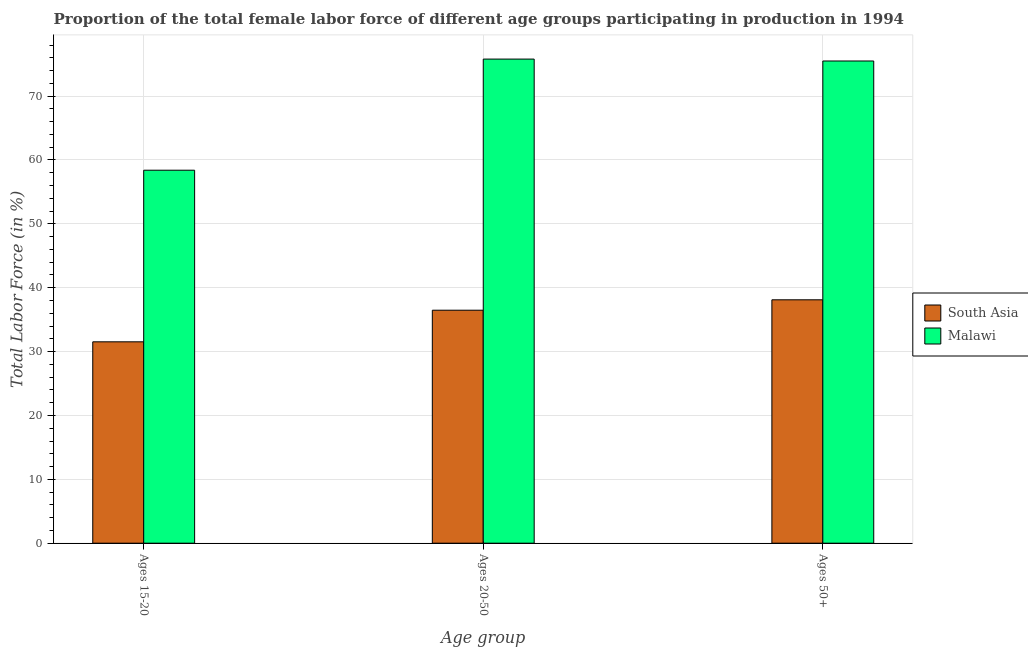Are the number of bars per tick equal to the number of legend labels?
Your answer should be very brief. Yes. Are the number of bars on each tick of the X-axis equal?
Your answer should be very brief. Yes. What is the label of the 2nd group of bars from the left?
Your answer should be compact. Ages 20-50. What is the percentage of female labor force above age 50 in Malawi?
Give a very brief answer. 75.5. Across all countries, what is the maximum percentage of female labor force above age 50?
Make the answer very short. 75.5. Across all countries, what is the minimum percentage of female labor force within the age group 15-20?
Your answer should be compact. 31.53. In which country was the percentage of female labor force within the age group 15-20 maximum?
Your answer should be very brief. Malawi. What is the total percentage of female labor force within the age group 20-50 in the graph?
Provide a succinct answer. 112.28. What is the difference between the percentage of female labor force within the age group 15-20 in Malawi and that in South Asia?
Provide a short and direct response. 26.87. What is the difference between the percentage of female labor force within the age group 15-20 in Malawi and the percentage of female labor force within the age group 20-50 in South Asia?
Give a very brief answer. 21.92. What is the average percentage of female labor force above age 50 per country?
Make the answer very short. 56.8. What is the difference between the percentage of female labor force within the age group 15-20 and percentage of female labor force within the age group 20-50 in South Asia?
Offer a terse response. -4.95. In how many countries, is the percentage of female labor force within the age group 15-20 greater than 18 %?
Your answer should be very brief. 2. What is the ratio of the percentage of female labor force within the age group 15-20 in Malawi to that in South Asia?
Ensure brevity in your answer.  1.85. Is the percentage of female labor force within the age group 15-20 in Malawi less than that in South Asia?
Keep it short and to the point. No. What is the difference between the highest and the second highest percentage of female labor force within the age group 15-20?
Keep it short and to the point. 26.87. What is the difference between the highest and the lowest percentage of female labor force within the age group 15-20?
Your response must be concise. 26.87. Is the sum of the percentage of female labor force above age 50 in South Asia and Malawi greater than the maximum percentage of female labor force within the age group 20-50 across all countries?
Your answer should be very brief. Yes. What does the 1st bar from the left in Ages 50+ represents?
Your response must be concise. South Asia. What does the 1st bar from the right in Ages 50+ represents?
Provide a succinct answer. Malawi. Is it the case that in every country, the sum of the percentage of female labor force within the age group 15-20 and percentage of female labor force within the age group 20-50 is greater than the percentage of female labor force above age 50?
Your answer should be very brief. Yes. Are all the bars in the graph horizontal?
Offer a terse response. No. How many legend labels are there?
Keep it short and to the point. 2. How are the legend labels stacked?
Provide a succinct answer. Vertical. What is the title of the graph?
Offer a very short reply. Proportion of the total female labor force of different age groups participating in production in 1994. Does "Iceland" appear as one of the legend labels in the graph?
Provide a short and direct response. No. What is the label or title of the X-axis?
Make the answer very short. Age group. What is the Total Labor Force (in %) of South Asia in Ages 15-20?
Offer a very short reply. 31.53. What is the Total Labor Force (in %) of Malawi in Ages 15-20?
Give a very brief answer. 58.4. What is the Total Labor Force (in %) in South Asia in Ages 20-50?
Your answer should be compact. 36.48. What is the Total Labor Force (in %) of Malawi in Ages 20-50?
Keep it short and to the point. 75.8. What is the Total Labor Force (in %) in South Asia in Ages 50+?
Offer a very short reply. 38.11. What is the Total Labor Force (in %) in Malawi in Ages 50+?
Keep it short and to the point. 75.5. Across all Age group, what is the maximum Total Labor Force (in %) in South Asia?
Offer a terse response. 38.11. Across all Age group, what is the maximum Total Labor Force (in %) of Malawi?
Your answer should be very brief. 75.8. Across all Age group, what is the minimum Total Labor Force (in %) of South Asia?
Keep it short and to the point. 31.53. Across all Age group, what is the minimum Total Labor Force (in %) of Malawi?
Make the answer very short. 58.4. What is the total Total Labor Force (in %) of South Asia in the graph?
Make the answer very short. 106.12. What is the total Total Labor Force (in %) of Malawi in the graph?
Your response must be concise. 209.7. What is the difference between the Total Labor Force (in %) in South Asia in Ages 15-20 and that in Ages 20-50?
Provide a succinct answer. -4.95. What is the difference between the Total Labor Force (in %) of Malawi in Ages 15-20 and that in Ages 20-50?
Provide a succinct answer. -17.4. What is the difference between the Total Labor Force (in %) of South Asia in Ages 15-20 and that in Ages 50+?
Give a very brief answer. -6.58. What is the difference between the Total Labor Force (in %) in Malawi in Ages 15-20 and that in Ages 50+?
Ensure brevity in your answer.  -17.1. What is the difference between the Total Labor Force (in %) in South Asia in Ages 20-50 and that in Ages 50+?
Keep it short and to the point. -1.63. What is the difference between the Total Labor Force (in %) of Malawi in Ages 20-50 and that in Ages 50+?
Your answer should be compact. 0.3. What is the difference between the Total Labor Force (in %) in South Asia in Ages 15-20 and the Total Labor Force (in %) in Malawi in Ages 20-50?
Provide a succinct answer. -44.27. What is the difference between the Total Labor Force (in %) in South Asia in Ages 15-20 and the Total Labor Force (in %) in Malawi in Ages 50+?
Provide a succinct answer. -43.97. What is the difference between the Total Labor Force (in %) in South Asia in Ages 20-50 and the Total Labor Force (in %) in Malawi in Ages 50+?
Provide a succinct answer. -39.02. What is the average Total Labor Force (in %) in South Asia per Age group?
Your answer should be compact. 35.37. What is the average Total Labor Force (in %) in Malawi per Age group?
Offer a very short reply. 69.9. What is the difference between the Total Labor Force (in %) of South Asia and Total Labor Force (in %) of Malawi in Ages 15-20?
Ensure brevity in your answer.  -26.87. What is the difference between the Total Labor Force (in %) in South Asia and Total Labor Force (in %) in Malawi in Ages 20-50?
Your response must be concise. -39.32. What is the difference between the Total Labor Force (in %) of South Asia and Total Labor Force (in %) of Malawi in Ages 50+?
Your answer should be compact. -37.39. What is the ratio of the Total Labor Force (in %) in South Asia in Ages 15-20 to that in Ages 20-50?
Your answer should be very brief. 0.86. What is the ratio of the Total Labor Force (in %) of Malawi in Ages 15-20 to that in Ages 20-50?
Keep it short and to the point. 0.77. What is the ratio of the Total Labor Force (in %) in South Asia in Ages 15-20 to that in Ages 50+?
Offer a terse response. 0.83. What is the ratio of the Total Labor Force (in %) in Malawi in Ages 15-20 to that in Ages 50+?
Give a very brief answer. 0.77. What is the ratio of the Total Labor Force (in %) in South Asia in Ages 20-50 to that in Ages 50+?
Provide a short and direct response. 0.96. What is the difference between the highest and the second highest Total Labor Force (in %) of South Asia?
Provide a short and direct response. 1.63. What is the difference between the highest and the second highest Total Labor Force (in %) of Malawi?
Give a very brief answer. 0.3. What is the difference between the highest and the lowest Total Labor Force (in %) of South Asia?
Your response must be concise. 6.58. What is the difference between the highest and the lowest Total Labor Force (in %) in Malawi?
Offer a terse response. 17.4. 